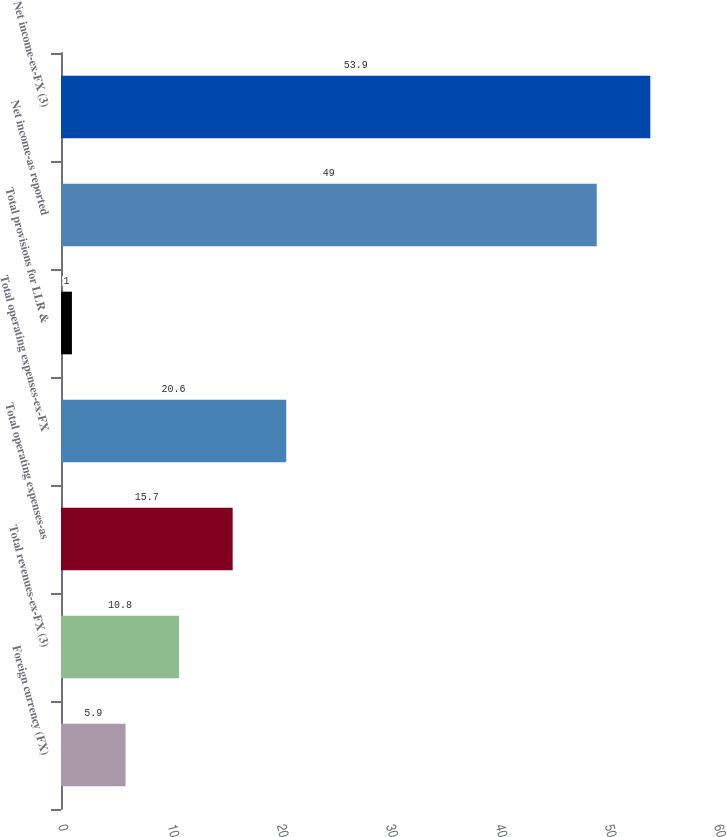<chart> <loc_0><loc_0><loc_500><loc_500><bar_chart><fcel>Foreign currency (FX)<fcel>Total revenues-ex-FX (3)<fcel>Total operating expenses-as<fcel>Total operating expenses-ex-FX<fcel>Total provisions for LLR &<fcel>Net income-as reported<fcel>Net income-ex-FX (3)<nl><fcel>5.9<fcel>10.8<fcel>15.7<fcel>20.6<fcel>1<fcel>49<fcel>53.9<nl></chart> 